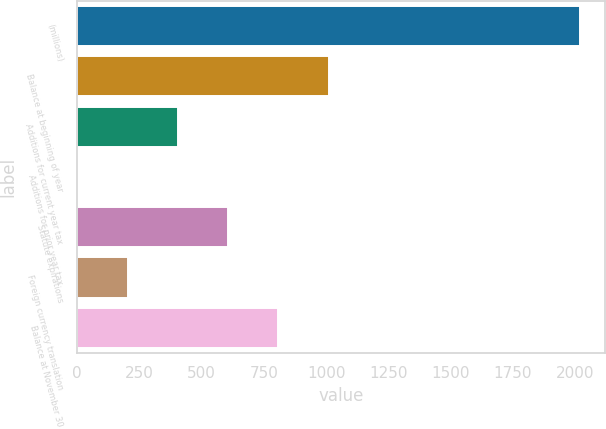Convert chart. <chart><loc_0><loc_0><loc_500><loc_500><bar_chart><fcel>(millions)<fcel>Balance at beginning of year<fcel>Additions for current year tax<fcel>Additions for prior year tax<fcel>Statute expirations<fcel>Foreign currency translation<fcel>Balance at November 30<nl><fcel>2018<fcel>1009.15<fcel>403.84<fcel>0.3<fcel>605.61<fcel>202.07<fcel>807.38<nl></chart> 